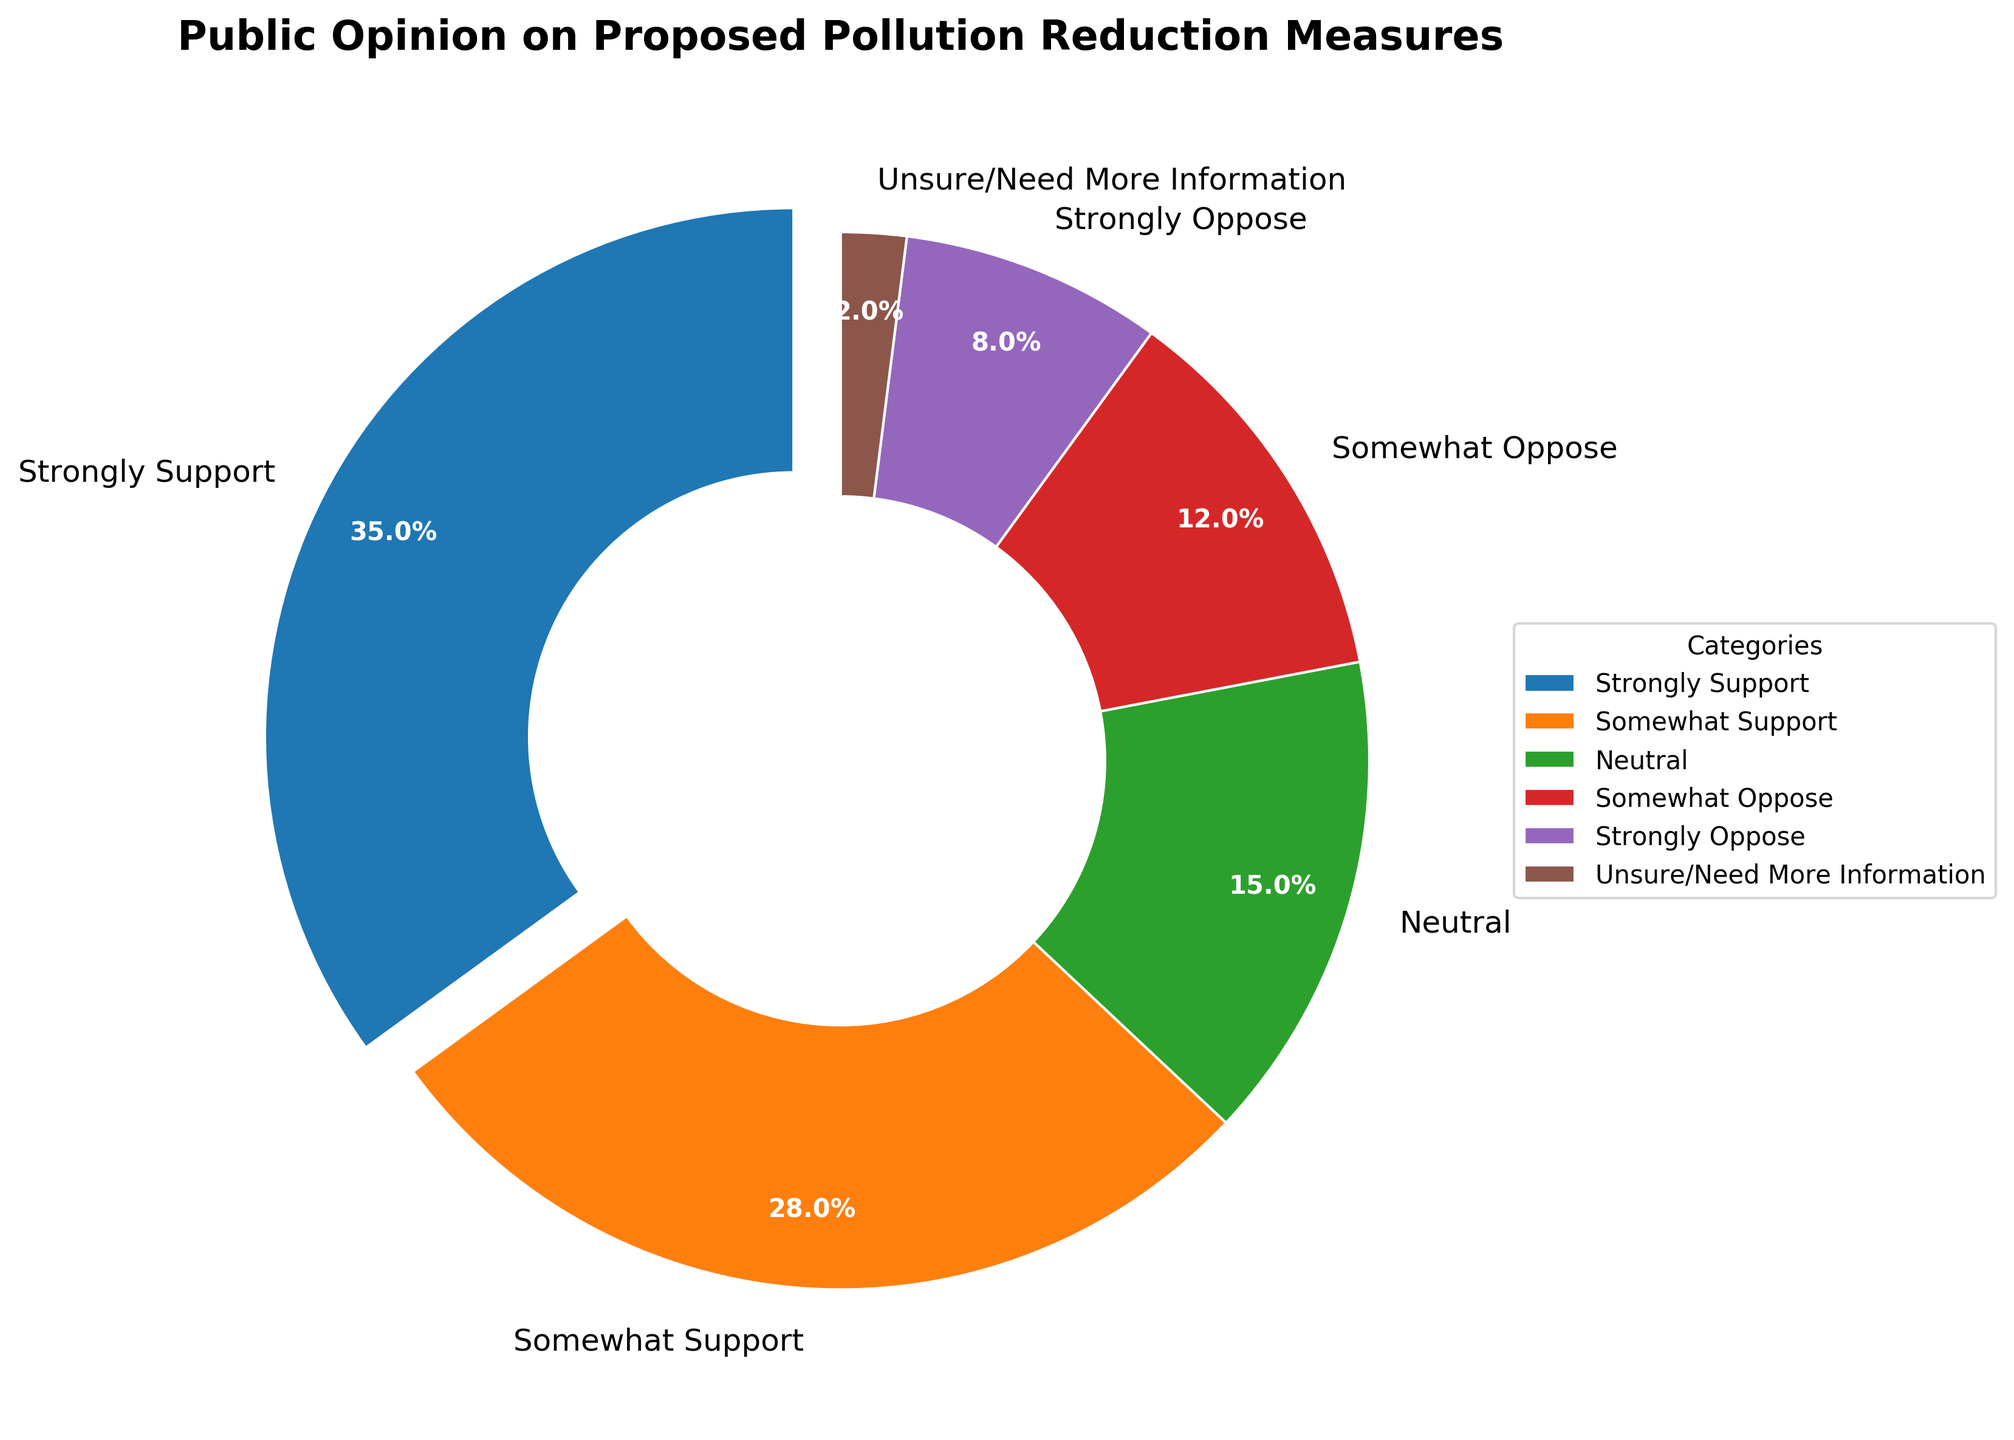Which category has the largest percentage of public support? The pie chart shows that the "Strongly Support" category is the largest slice of the pie.
Answer: Strongly Support What is the combined percentage of those who are either somewhat supportive or strongly supportive? The percentages for "Somewhat Support" and "Strongly Support" are 28% and 35% respectively. Adding these together gives 63%.
Answer: 63% Which category has the smallest percentage? The pie chart shows that the "Unsure/Need More Information" category has the smallest slice of the pie.
Answer: Unsure/Need More Information How does the percentage of those who somewhat oppose compare to those who strongly oppose? The percentage for "Somewhat Oppose" is 12%, while the percentage for "Strongly Oppose" is 8%. Thus, somewhat oppose is 4% higher than strongly oppose.
Answer: 4% higher What is the difference in public sentiment between those who are neutral and those who are strongly opposed? The percentage for "Neutral" is 15%, and the percentage for "Strongly Oppose" is 8%. So the difference is 7%.
Answer: 7% What do you notice about the colors representing public opinion categories? The pie chart uses distinct colors for each category to clearly distinguish them. "Strongly Support" is blue, "Somewhat Support" is orange, "Neutral" is green, "Somewhat Oppose" is red, "Strongly Oppose" is purple, and "Unsure/Need More Information" is brown.
Answer: Distinct colors What's the proportion of respondents who do not oppose the measures (Neutral and both supportive categories combined) compared to the total respondents? Adding up the percentages of "Strongly Support," "Somewhat Support," and "Neutral" gives (35+28+15=78)%. The proportion compared to 100% is 78%.
Answer: 78% What fraction of the public is either somewhat opposed or strongly opposed to the measures? Adding the percentages of "Somewhat Oppose" (12%) and "Strongly Oppose" (8%) gives 20%.
Answer: 20% How much larger is the "Strongly Support" category compared to the "Neutral" category? The percentage for "Strongly Support" is 35%, and for "Neutral" it is 15%. The difference is 20%.
Answer: 20% What percentage of people are either unsure or in need of more information? The pie chart indicates that "Unsure/Need More Information" accounts for 2%.
Answer: 2% 